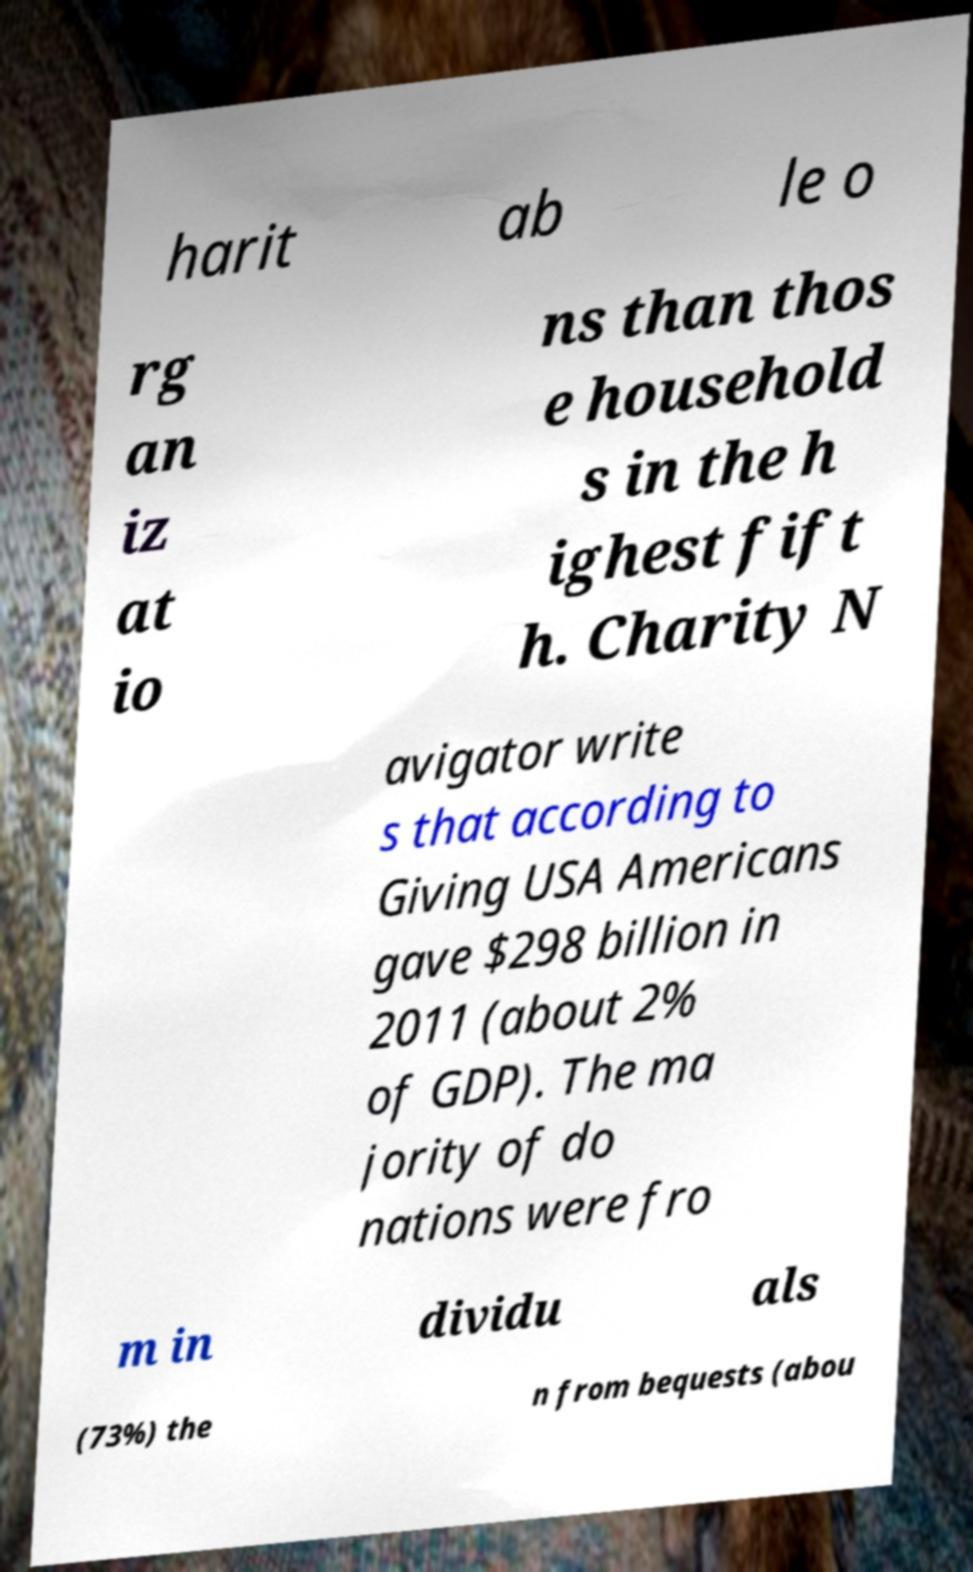There's text embedded in this image that I need extracted. Can you transcribe it verbatim? harit ab le o rg an iz at io ns than thos e household s in the h ighest fift h. Charity N avigator write s that according to Giving USA Americans gave $298 billion in 2011 (about 2% of GDP). The ma jority of do nations were fro m in dividu als (73%) the n from bequests (abou 